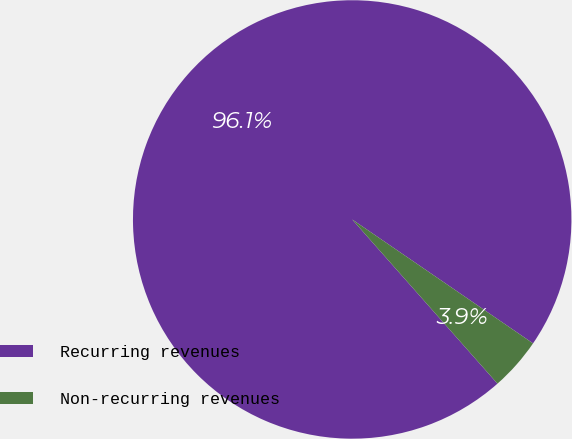<chart> <loc_0><loc_0><loc_500><loc_500><pie_chart><fcel>Recurring revenues<fcel>Non-recurring revenues<nl><fcel>96.09%<fcel>3.91%<nl></chart> 